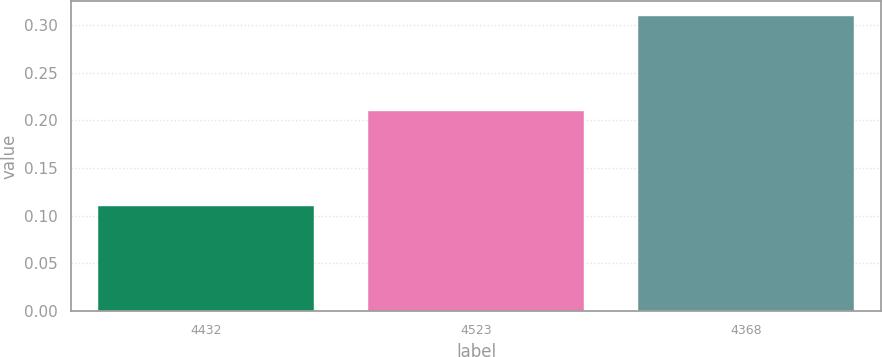<chart> <loc_0><loc_0><loc_500><loc_500><bar_chart><fcel>4432<fcel>4523<fcel>4368<nl><fcel>0.11<fcel>0.21<fcel>0.31<nl></chart> 